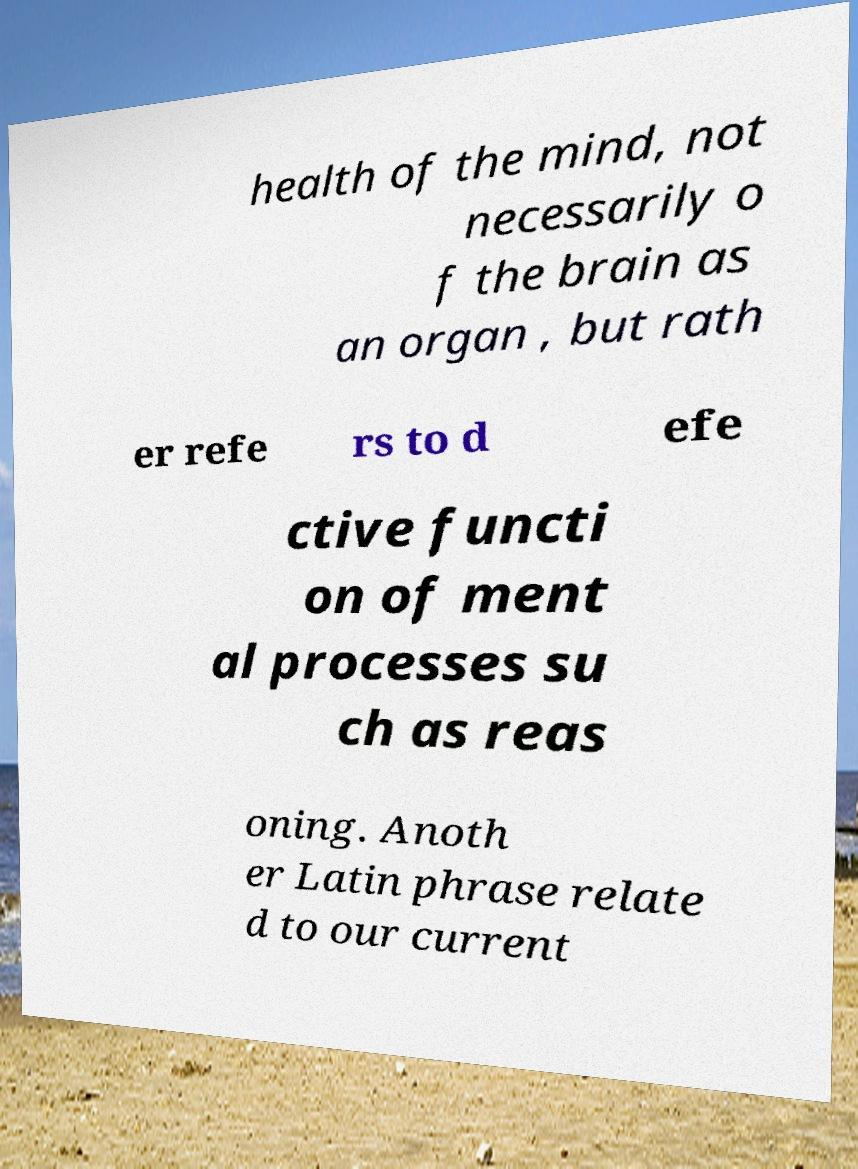What messages or text are displayed in this image? I need them in a readable, typed format. health of the mind, not necessarily o f the brain as an organ , but rath er refe rs to d efe ctive functi on of ment al processes su ch as reas oning. Anoth er Latin phrase relate d to our current 